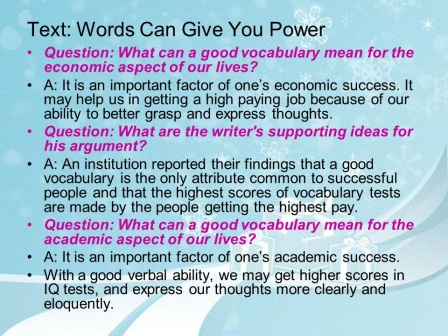Can you describe the main features of this image for me? The image is a slide from a presentation designed with a visually appealing background. The slide features a bright blue backdrop dotted with white snowflakes, creating a cool and calming atmosphere. A pink border frames the entire slide, adding a touch of warmth and contrast. The title, "Text: Words Can Give You Power", is placed prominently at the top in a bold, white font, making it easily noticeable. Below the title, the slide is divided into three segments, each featuring a question in magenta text followed by a detailed answer in white text, discussing the significance of a robust vocabulary both economically and academically. The response sections are well-spaced and organized, contributing to a clear and professional layout. 